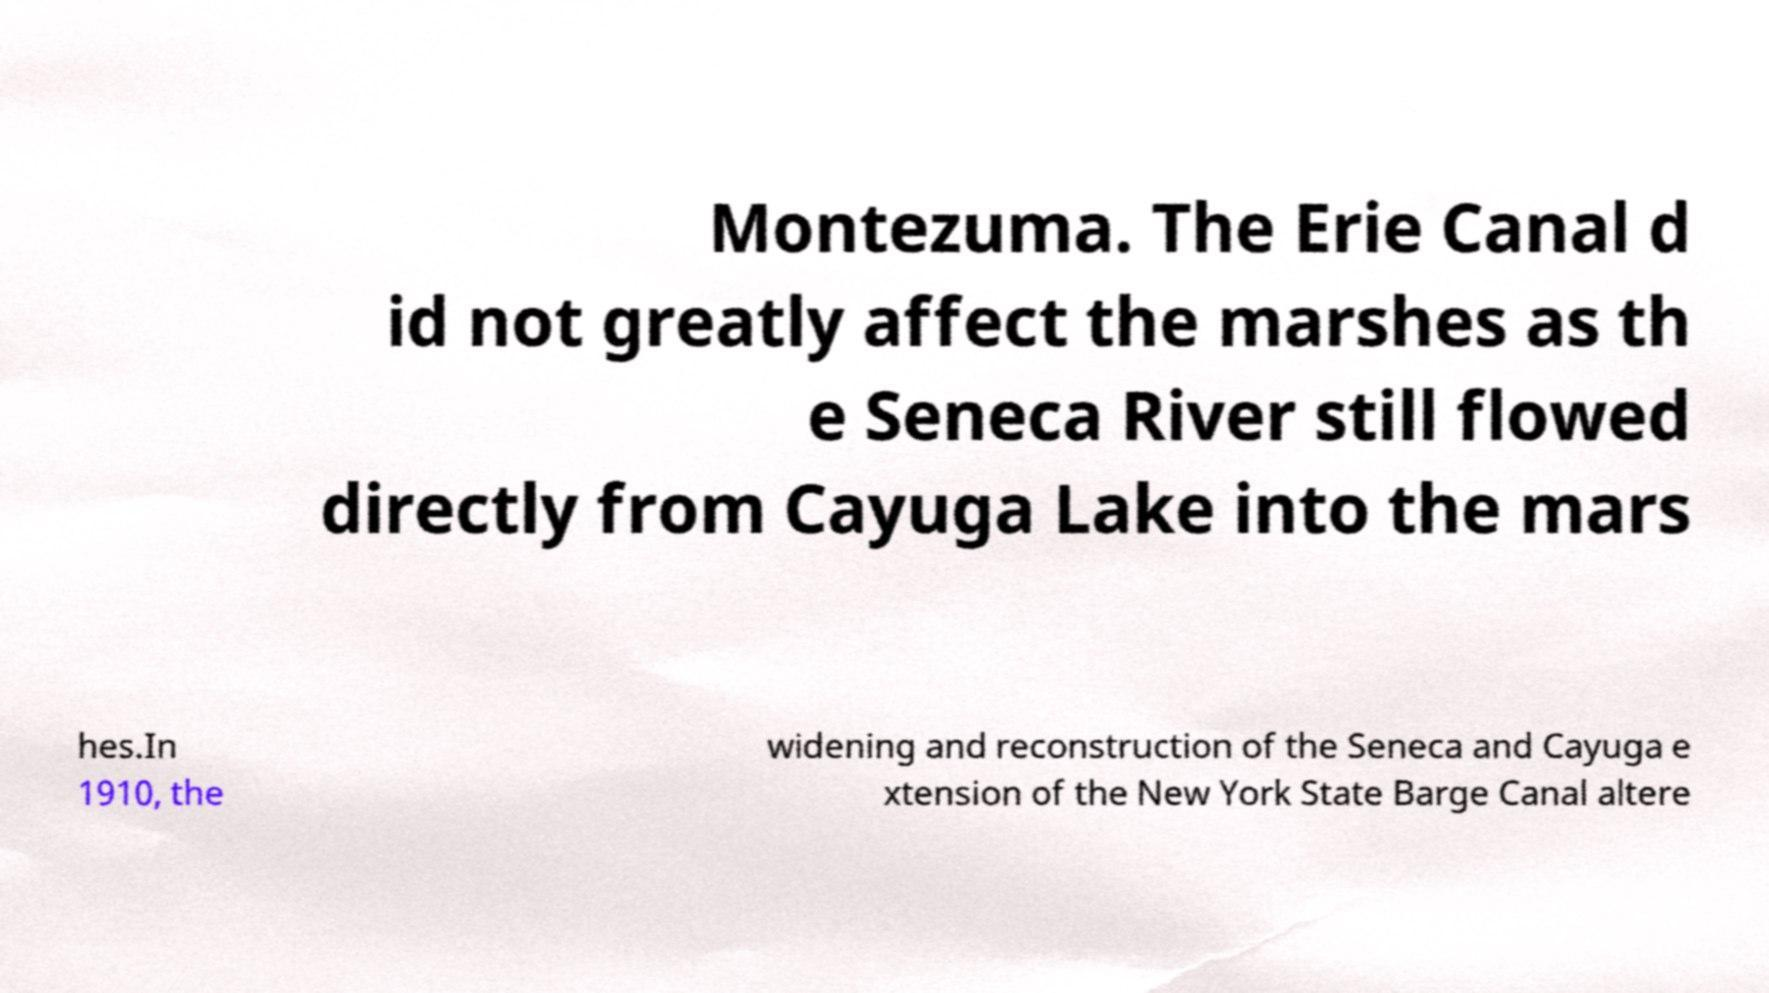There's text embedded in this image that I need extracted. Can you transcribe it verbatim? Montezuma. The Erie Canal d id not greatly affect the marshes as th e Seneca River still flowed directly from Cayuga Lake into the mars hes.In 1910, the widening and reconstruction of the Seneca and Cayuga e xtension of the New York State Barge Canal altere 